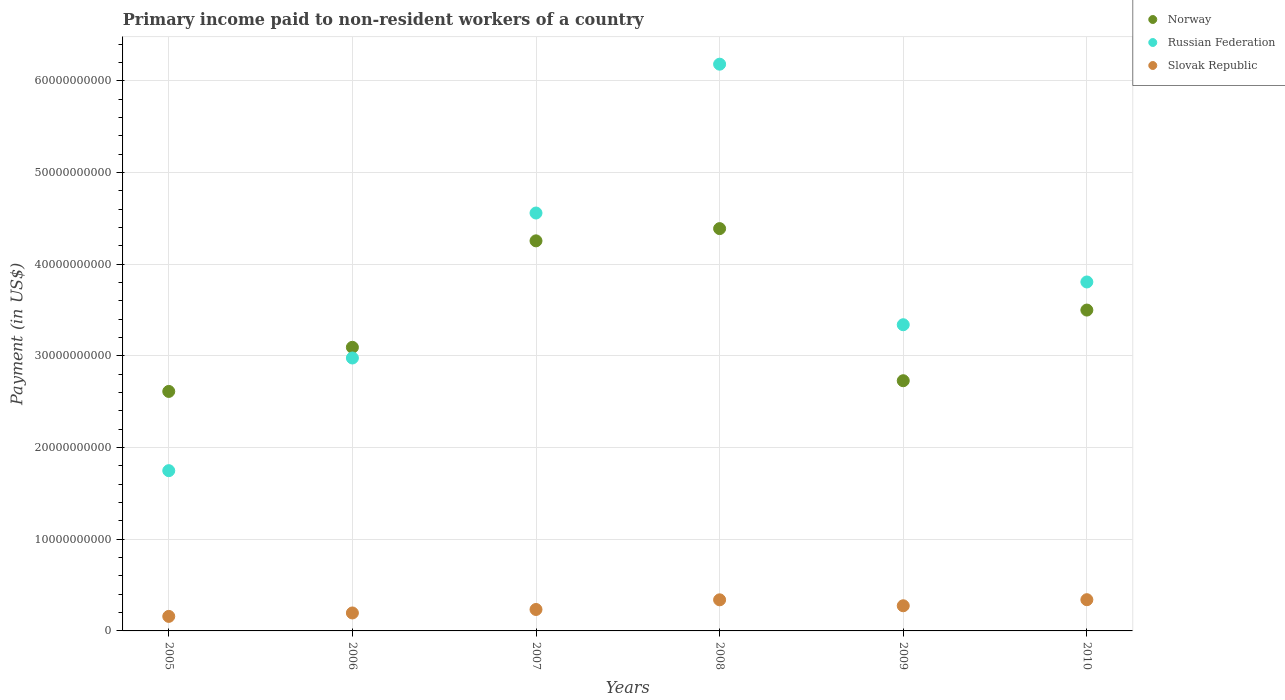How many different coloured dotlines are there?
Offer a terse response. 3. What is the amount paid to workers in Russian Federation in 2010?
Your response must be concise. 3.81e+1. Across all years, what is the maximum amount paid to workers in Slovak Republic?
Make the answer very short. 3.41e+09. Across all years, what is the minimum amount paid to workers in Russian Federation?
Keep it short and to the point. 1.75e+1. In which year was the amount paid to workers in Slovak Republic maximum?
Offer a very short reply. 2010. In which year was the amount paid to workers in Russian Federation minimum?
Keep it short and to the point. 2005. What is the total amount paid to workers in Norway in the graph?
Provide a succinct answer. 2.06e+11. What is the difference between the amount paid to workers in Slovak Republic in 2008 and that in 2009?
Offer a very short reply. 6.49e+08. What is the difference between the amount paid to workers in Norway in 2005 and the amount paid to workers in Slovak Republic in 2010?
Your response must be concise. 2.27e+1. What is the average amount paid to workers in Norway per year?
Make the answer very short. 3.43e+1. In the year 2005, what is the difference between the amount paid to workers in Slovak Republic and amount paid to workers in Norway?
Provide a short and direct response. -2.45e+1. In how many years, is the amount paid to workers in Russian Federation greater than 20000000000 US$?
Offer a terse response. 5. What is the ratio of the amount paid to workers in Slovak Republic in 2005 to that in 2008?
Keep it short and to the point. 0.47. Is the amount paid to workers in Norway in 2007 less than that in 2009?
Keep it short and to the point. No. What is the difference between the highest and the second highest amount paid to workers in Norway?
Your answer should be very brief. 1.33e+09. What is the difference between the highest and the lowest amount paid to workers in Slovak Republic?
Your response must be concise. 1.82e+09. Is the sum of the amount paid to workers in Norway in 2005 and 2009 greater than the maximum amount paid to workers in Russian Federation across all years?
Your response must be concise. No. Does the amount paid to workers in Norway monotonically increase over the years?
Ensure brevity in your answer.  No. Is the amount paid to workers in Russian Federation strictly greater than the amount paid to workers in Slovak Republic over the years?
Your answer should be very brief. Yes. Is the amount paid to workers in Russian Federation strictly less than the amount paid to workers in Norway over the years?
Give a very brief answer. No. How many dotlines are there?
Your response must be concise. 3. How many years are there in the graph?
Your answer should be compact. 6. What is the difference between two consecutive major ticks on the Y-axis?
Provide a succinct answer. 1.00e+1. Are the values on the major ticks of Y-axis written in scientific E-notation?
Make the answer very short. No. Does the graph contain any zero values?
Keep it short and to the point. No. Does the graph contain grids?
Your answer should be very brief. Yes. Where does the legend appear in the graph?
Your response must be concise. Top right. How many legend labels are there?
Keep it short and to the point. 3. How are the legend labels stacked?
Keep it short and to the point. Vertical. What is the title of the graph?
Your answer should be compact. Primary income paid to non-resident workers of a country. What is the label or title of the Y-axis?
Give a very brief answer. Payment (in US$). What is the Payment (in US$) in Norway in 2005?
Provide a succinct answer. 2.61e+1. What is the Payment (in US$) in Russian Federation in 2005?
Your answer should be very brief. 1.75e+1. What is the Payment (in US$) in Slovak Republic in 2005?
Ensure brevity in your answer.  1.58e+09. What is the Payment (in US$) of Norway in 2006?
Provide a short and direct response. 3.09e+1. What is the Payment (in US$) of Russian Federation in 2006?
Your response must be concise. 2.98e+1. What is the Payment (in US$) in Slovak Republic in 2006?
Your response must be concise. 1.96e+09. What is the Payment (in US$) in Norway in 2007?
Provide a short and direct response. 4.25e+1. What is the Payment (in US$) of Russian Federation in 2007?
Keep it short and to the point. 4.56e+1. What is the Payment (in US$) in Slovak Republic in 2007?
Your answer should be very brief. 2.34e+09. What is the Payment (in US$) of Norway in 2008?
Keep it short and to the point. 4.39e+1. What is the Payment (in US$) in Russian Federation in 2008?
Your answer should be very brief. 6.18e+1. What is the Payment (in US$) in Slovak Republic in 2008?
Give a very brief answer. 3.39e+09. What is the Payment (in US$) in Norway in 2009?
Keep it short and to the point. 2.73e+1. What is the Payment (in US$) in Russian Federation in 2009?
Provide a short and direct response. 3.34e+1. What is the Payment (in US$) in Slovak Republic in 2009?
Your answer should be compact. 2.74e+09. What is the Payment (in US$) in Norway in 2010?
Provide a short and direct response. 3.50e+1. What is the Payment (in US$) of Russian Federation in 2010?
Make the answer very short. 3.81e+1. What is the Payment (in US$) in Slovak Republic in 2010?
Provide a succinct answer. 3.41e+09. Across all years, what is the maximum Payment (in US$) of Norway?
Provide a short and direct response. 4.39e+1. Across all years, what is the maximum Payment (in US$) of Russian Federation?
Provide a succinct answer. 6.18e+1. Across all years, what is the maximum Payment (in US$) of Slovak Republic?
Your answer should be very brief. 3.41e+09. Across all years, what is the minimum Payment (in US$) of Norway?
Your response must be concise. 2.61e+1. Across all years, what is the minimum Payment (in US$) of Russian Federation?
Provide a succinct answer. 1.75e+1. Across all years, what is the minimum Payment (in US$) in Slovak Republic?
Your response must be concise. 1.58e+09. What is the total Payment (in US$) in Norway in the graph?
Offer a very short reply. 2.06e+11. What is the total Payment (in US$) of Russian Federation in the graph?
Your answer should be very brief. 2.26e+11. What is the total Payment (in US$) of Slovak Republic in the graph?
Make the answer very short. 1.54e+1. What is the difference between the Payment (in US$) in Norway in 2005 and that in 2006?
Ensure brevity in your answer.  -4.81e+09. What is the difference between the Payment (in US$) of Russian Federation in 2005 and that in 2006?
Ensure brevity in your answer.  -1.23e+1. What is the difference between the Payment (in US$) in Slovak Republic in 2005 and that in 2006?
Provide a short and direct response. -3.74e+08. What is the difference between the Payment (in US$) in Norway in 2005 and that in 2007?
Provide a succinct answer. -1.64e+1. What is the difference between the Payment (in US$) in Russian Federation in 2005 and that in 2007?
Give a very brief answer. -2.81e+1. What is the difference between the Payment (in US$) of Slovak Republic in 2005 and that in 2007?
Offer a very short reply. -7.55e+08. What is the difference between the Payment (in US$) in Norway in 2005 and that in 2008?
Provide a short and direct response. -1.78e+1. What is the difference between the Payment (in US$) in Russian Federation in 2005 and that in 2008?
Your response must be concise. -4.43e+1. What is the difference between the Payment (in US$) in Slovak Republic in 2005 and that in 2008?
Provide a short and direct response. -1.81e+09. What is the difference between the Payment (in US$) in Norway in 2005 and that in 2009?
Make the answer very short. -1.17e+09. What is the difference between the Payment (in US$) in Russian Federation in 2005 and that in 2009?
Your answer should be very brief. -1.59e+1. What is the difference between the Payment (in US$) in Slovak Republic in 2005 and that in 2009?
Your answer should be very brief. -1.16e+09. What is the difference between the Payment (in US$) of Norway in 2005 and that in 2010?
Give a very brief answer. -8.88e+09. What is the difference between the Payment (in US$) in Russian Federation in 2005 and that in 2010?
Your answer should be compact. -2.06e+1. What is the difference between the Payment (in US$) in Slovak Republic in 2005 and that in 2010?
Make the answer very short. -1.82e+09. What is the difference between the Payment (in US$) of Norway in 2006 and that in 2007?
Provide a short and direct response. -1.16e+1. What is the difference between the Payment (in US$) in Russian Federation in 2006 and that in 2007?
Make the answer very short. -1.58e+1. What is the difference between the Payment (in US$) in Slovak Republic in 2006 and that in 2007?
Your answer should be compact. -3.81e+08. What is the difference between the Payment (in US$) in Norway in 2006 and that in 2008?
Give a very brief answer. -1.29e+1. What is the difference between the Payment (in US$) in Russian Federation in 2006 and that in 2008?
Your answer should be very brief. -3.20e+1. What is the difference between the Payment (in US$) of Slovak Republic in 2006 and that in 2008?
Provide a succinct answer. -1.43e+09. What is the difference between the Payment (in US$) of Norway in 2006 and that in 2009?
Give a very brief answer. 3.64e+09. What is the difference between the Payment (in US$) of Russian Federation in 2006 and that in 2009?
Provide a succinct answer. -3.63e+09. What is the difference between the Payment (in US$) in Slovak Republic in 2006 and that in 2009?
Offer a very short reply. -7.85e+08. What is the difference between the Payment (in US$) of Norway in 2006 and that in 2010?
Keep it short and to the point. -4.06e+09. What is the difference between the Payment (in US$) in Russian Federation in 2006 and that in 2010?
Keep it short and to the point. -8.29e+09. What is the difference between the Payment (in US$) of Slovak Republic in 2006 and that in 2010?
Offer a terse response. -1.45e+09. What is the difference between the Payment (in US$) in Norway in 2007 and that in 2008?
Your answer should be very brief. -1.33e+09. What is the difference between the Payment (in US$) of Russian Federation in 2007 and that in 2008?
Provide a short and direct response. -1.62e+1. What is the difference between the Payment (in US$) in Slovak Republic in 2007 and that in 2008?
Your answer should be compact. -1.05e+09. What is the difference between the Payment (in US$) in Norway in 2007 and that in 2009?
Offer a very short reply. 1.53e+1. What is the difference between the Payment (in US$) of Russian Federation in 2007 and that in 2009?
Offer a very short reply. 1.22e+1. What is the difference between the Payment (in US$) of Slovak Republic in 2007 and that in 2009?
Ensure brevity in your answer.  -4.04e+08. What is the difference between the Payment (in US$) of Norway in 2007 and that in 2010?
Your answer should be compact. 7.55e+09. What is the difference between the Payment (in US$) of Russian Federation in 2007 and that in 2010?
Offer a very short reply. 7.52e+09. What is the difference between the Payment (in US$) of Slovak Republic in 2007 and that in 2010?
Provide a succinct answer. -1.07e+09. What is the difference between the Payment (in US$) in Norway in 2008 and that in 2009?
Offer a terse response. 1.66e+1. What is the difference between the Payment (in US$) in Russian Federation in 2008 and that in 2009?
Provide a succinct answer. 2.84e+1. What is the difference between the Payment (in US$) of Slovak Republic in 2008 and that in 2009?
Your response must be concise. 6.49e+08. What is the difference between the Payment (in US$) in Norway in 2008 and that in 2010?
Give a very brief answer. 8.88e+09. What is the difference between the Payment (in US$) of Russian Federation in 2008 and that in 2010?
Your answer should be compact. 2.38e+1. What is the difference between the Payment (in US$) in Slovak Republic in 2008 and that in 2010?
Your response must be concise. -1.33e+07. What is the difference between the Payment (in US$) of Norway in 2009 and that in 2010?
Ensure brevity in your answer.  -7.71e+09. What is the difference between the Payment (in US$) of Russian Federation in 2009 and that in 2010?
Offer a terse response. -4.66e+09. What is the difference between the Payment (in US$) in Slovak Republic in 2009 and that in 2010?
Offer a terse response. -6.62e+08. What is the difference between the Payment (in US$) of Norway in 2005 and the Payment (in US$) of Russian Federation in 2006?
Offer a very short reply. -3.65e+09. What is the difference between the Payment (in US$) of Norway in 2005 and the Payment (in US$) of Slovak Republic in 2006?
Provide a succinct answer. 2.42e+1. What is the difference between the Payment (in US$) in Russian Federation in 2005 and the Payment (in US$) in Slovak Republic in 2006?
Your answer should be compact. 1.55e+1. What is the difference between the Payment (in US$) of Norway in 2005 and the Payment (in US$) of Russian Federation in 2007?
Give a very brief answer. -1.95e+1. What is the difference between the Payment (in US$) of Norway in 2005 and the Payment (in US$) of Slovak Republic in 2007?
Make the answer very short. 2.38e+1. What is the difference between the Payment (in US$) of Russian Federation in 2005 and the Payment (in US$) of Slovak Republic in 2007?
Offer a terse response. 1.51e+1. What is the difference between the Payment (in US$) of Norway in 2005 and the Payment (in US$) of Russian Federation in 2008?
Provide a succinct answer. -3.57e+1. What is the difference between the Payment (in US$) of Norway in 2005 and the Payment (in US$) of Slovak Republic in 2008?
Provide a succinct answer. 2.27e+1. What is the difference between the Payment (in US$) of Russian Federation in 2005 and the Payment (in US$) of Slovak Republic in 2008?
Offer a very short reply. 1.41e+1. What is the difference between the Payment (in US$) of Norway in 2005 and the Payment (in US$) of Russian Federation in 2009?
Ensure brevity in your answer.  -7.28e+09. What is the difference between the Payment (in US$) of Norway in 2005 and the Payment (in US$) of Slovak Republic in 2009?
Give a very brief answer. 2.34e+1. What is the difference between the Payment (in US$) in Russian Federation in 2005 and the Payment (in US$) in Slovak Republic in 2009?
Make the answer very short. 1.47e+1. What is the difference between the Payment (in US$) of Norway in 2005 and the Payment (in US$) of Russian Federation in 2010?
Make the answer very short. -1.19e+1. What is the difference between the Payment (in US$) of Norway in 2005 and the Payment (in US$) of Slovak Republic in 2010?
Offer a very short reply. 2.27e+1. What is the difference between the Payment (in US$) in Russian Federation in 2005 and the Payment (in US$) in Slovak Republic in 2010?
Give a very brief answer. 1.41e+1. What is the difference between the Payment (in US$) in Norway in 2006 and the Payment (in US$) in Russian Federation in 2007?
Offer a very short reply. -1.46e+1. What is the difference between the Payment (in US$) in Norway in 2006 and the Payment (in US$) in Slovak Republic in 2007?
Your answer should be compact. 2.86e+1. What is the difference between the Payment (in US$) of Russian Federation in 2006 and the Payment (in US$) of Slovak Republic in 2007?
Your response must be concise. 2.74e+1. What is the difference between the Payment (in US$) of Norway in 2006 and the Payment (in US$) of Russian Federation in 2008?
Provide a short and direct response. -3.09e+1. What is the difference between the Payment (in US$) of Norway in 2006 and the Payment (in US$) of Slovak Republic in 2008?
Keep it short and to the point. 2.75e+1. What is the difference between the Payment (in US$) in Russian Federation in 2006 and the Payment (in US$) in Slovak Republic in 2008?
Your answer should be very brief. 2.64e+1. What is the difference between the Payment (in US$) of Norway in 2006 and the Payment (in US$) of Russian Federation in 2009?
Provide a short and direct response. -2.46e+09. What is the difference between the Payment (in US$) in Norway in 2006 and the Payment (in US$) in Slovak Republic in 2009?
Keep it short and to the point. 2.82e+1. What is the difference between the Payment (in US$) of Russian Federation in 2006 and the Payment (in US$) of Slovak Republic in 2009?
Give a very brief answer. 2.70e+1. What is the difference between the Payment (in US$) of Norway in 2006 and the Payment (in US$) of Russian Federation in 2010?
Offer a terse response. -7.13e+09. What is the difference between the Payment (in US$) of Norway in 2006 and the Payment (in US$) of Slovak Republic in 2010?
Your response must be concise. 2.75e+1. What is the difference between the Payment (in US$) of Russian Federation in 2006 and the Payment (in US$) of Slovak Republic in 2010?
Offer a very short reply. 2.64e+1. What is the difference between the Payment (in US$) in Norway in 2007 and the Payment (in US$) in Russian Federation in 2008?
Give a very brief answer. -1.93e+1. What is the difference between the Payment (in US$) in Norway in 2007 and the Payment (in US$) in Slovak Republic in 2008?
Your answer should be very brief. 3.92e+1. What is the difference between the Payment (in US$) in Russian Federation in 2007 and the Payment (in US$) in Slovak Republic in 2008?
Your answer should be compact. 4.22e+1. What is the difference between the Payment (in US$) in Norway in 2007 and the Payment (in US$) in Russian Federation in 2009?
Offer a terse response. 9.15e+09. What is the difference between the Payment (in US$) in Norway in 2007 and the Payment (in US$) in Slovak Republic in 2009?
Give a very brief answer. 3.98e+1. What is the difference between the Payment (in US$) in Russian Federation in 2007 and the Payment (in US$) in Slovak Republic in 2009?
Provide a short and direct response. 4.28e+1. What is the difference between the Payment (in US$) in Norway in 2007 and the Payment (in US$) in Russian Federation in 2010?
Offer a terse response. 4.49e+09. What is the difference between the Payment (in US$) of Norway in 2007 and the Payment (in US$) of Slovak Republic in 2010?
Make the answer very short. 3.91e+1. What is the difference between the Payment (in US$) of Russian Federation in 2007 and the Payment (in US$) of Slovak Republic in 2010?
Provide a succinct answer. 4.22e+1. What is the difference between the Payment (in US$) of Norway in 2008 and the Payment (in US$) of Russian Federation in 2009?
Your answer should be compact. 1.05e+1. What is the difference between the Payment (in US$) in Norway in 2008 and the Payment (in US$) in Slovak Republic in 2009?
Offer a very short reply. 4.11e+1. What is the difference between the Payment (in US$) of Russian Federation in 2008 and the Payment (in US$) of Slovak Republic in 2009?
Provide a succinct answer. 5.91e+1. What is the difference between the Payment (in US$) in Norway in 2008 and the Payment (in US$) in Russian Federation in 2010?
Make the answer very short. 5.82e+09. What is the difference between the Payment (in US$) in Norway in 2008 and the Payment (in US$) in Slovak Republic in 2010?
Offer a very short reply. 4.05e+1. What is the difference between the Payment (in US$) in Russian Federation in 2008 and the Payment (in US$) in Slovak Republic in 2010?
Keep it short and to the point. 5.84e+1. What is the difference between the Payment (in US$) of Norway in 2009 and the Payment (in US$) of Russian Federation in 2010?
Make the answer very short. -1.08e+1. What is the difference between the Payment (in US$) of Norway in 2009 and the Payment (in US$) of Slovak Republic in 2010?
Your answer should be compact. 2.39e+1. What is the difference between the Payment (in US$) of Russian Federation in 2009 and the Payment (in US$) of Slovak Republic in 2010?
Ensure brevity in your answer.  3.00e+1. What is the average Payment (in US$) in Norway per year?
Give a very brief answer. 3.43e+1. What is the average Payment (in US$) of Russian Federation per year?
Provide a short and direct response. 3.77e+1. What is the average Payment (in US$) of Slovak Republic per year?
Make the answer very short. 2.57e+09. In the year 2005, what is the difference between the Payment (in US$) in Norway and Payment (in US$) in Russian Federation?
Your answer should be very brief. 8.64e+09. In the year 2005, what is the difference between the Payment (in US$) of Norway and Payment (in US$) of Slovak Republic?
Keep it short and to the point. 2.45e+1. In the year 2005, what is the difference between the Payment (in US$) of Russian Federation and Payment (in US$) of Slovak Republic?
Make the answer very short. 1.59e+1. In the year 2006, what is the difference between the Payment (in US$) of Norway and Payment (in US$) of Russian Federation?
Your answer should be very brief. 1.17e+09. In the year 2006, what is the difference between the Payment (in US$) of Norway and Payment (in US$) of Slovak Republic?
Offer a terse response. 2.90e+1. In the year 2006, what is the difference between the Payment (in US$) in Russian Federation and Payment (in US$) in Slovak Republic?
Keep it short and to the point. 2.78e+1. In the year 2007, what is the difference between the Payment (in US$) of Norway and Payment (in US$) of Russian Federation?
Offer a very short reply. -3.03e+09. In the year 2007, what is the difference between the Payment (in US$) of Norway and Payment (in US$) of Slovak Republic?
Your response must be concise. 4.02e+1. In the year 2007, what is the difference between the Payment (in US$) in Russian Federation and Payment (in US$) in Slovak Republic?
Your answer should be very brief. 4.32e+1. In the year 2008, what is the difference between the Payment (in US$) of Norway and Payment (in US$) of Russian Federation?
Offer a very short reply. -1.79e+1. In the year 2008, what is the difference between the Payment (in US$) of Norway and Payment (in US$) of Slovak Republic?
Keep it short and to the point. 4.05e+1. In the year 2008, what is the difference between the Payment (in US$) in Russian Federation and Payment (in US$) in Slovak Republic?
Keep it short and to the point. 5.84e+1. In the year 2009, what is the difference between the Payment (in US$) in Norway and Payment (in US$) in Russian Federation?
Provide a short and direct response. -6.11e+09. In the year 2009, what is the difference between the Payment (in US$) of Norway and Payment (in US$) of Slovak Republic?
Your answer should be very brief. 2.45e+1. In the year 2009, what is the difference between the Payment (in US$) of Russian Federation and Payment (in US$) of Slovak Republic?
Ensure brevity in your answer.  3.07e+1. In the year 2010, what is the difference between the Payment (in US$) of Norway and Payment (in US$) of Russian Federation?
Your response must be concise. -3.06e+09. In the year 2010, what is the difference between the Payment (in US$) of Norway and Payment (in US$) of Slovak Republic?
Provide a short and direct response. 3.16e+1. In the year 2010, what is the difference between the Payment (in US$) in Russian Federation and Payment (in US$) in Slovak Republic?
Make the answer very short. 3.47e+1. What is the ratio of the Payment (in US$) of Norway in 2005 to that in 2006?
Offer a very short reply. 0.84. What is the ratio of the Payment (in US$) of Russian Federation in 2005 to that in 2006?
Provide a short and direct response. 0.59. What is the ratio of the Payment (in US$) of Slovak Republic in 2005 to that in 2006?
Your answer should be compact. 0.81. What is the ratio of the Payment (in US$) in Norway in 2005 to that in 2007?
Keep it short and to the point. 0.61. What is the ratio of the Payment (in US$) in Russian Federation in 2005 to that in 2007?
Keep it short and to the point. 0.38. What is the ratio of the Payment (in US$) of Slovak Republic in 2005 to that in 2007?
Keep it short and to the point. 0.68. What is the ratio of the Payment (in US$) of Norway in 2005 to that in 2008?
Offer a terse response. 0.6. What is the ratio of the Payment (in US$) in Russian Federation in 2005 to that in 2008?
Keep it short and to the point. 0.28. What is the ratio of the Payment (in US$) of Slovak Republic in 2005 to that in 2008?
Your answer should be compact. 0.47. What is the ratio of the Payment (in US$) of Norway in 2005 to that in 2009?
Your response must be concise. 0.96. What is the ratio of the Payment (in US$) in Russian Federation in 2005 to that in 2009?
Your response must be concise. 0.52. What is the ratio of the Payment (in US$) of Slovak Republic in 2005 to that in 2009?
Ensure brevity in your answer.  0.58. What is the ratio of the Payment (in US$) in Norway in 2005 to that in 2010?
Your answer should be very brief. 0.75. What is the ratio of the Payment (in US$) in Russian Federation in 2005 to that in 2010?
Ensure brevity in your answer.  0.46. What is the ratio of the Payment (in US$) of Slovak Republic in 2005 to that in 2010?
Offer a terse response. 0.47. What is the ratio of the Payment (in US$) in Norway in 2006 to that in 2007?
Offer a very short reply. 0.73. What is the ratio of the Payment (in US$) in Russian Federation in 2006 to that in 2007?
Your answer should be very brief. 0.65. What is the ratio of the Payment (in US$) of Slovak Republic in 2006 to that in 2007?
Ensure brevity in your answer.  0.84. What is the ratio of the Payment (in US$) of Norway in 2006 to that in 2008?
Your answer should be very brief. 0.7. What is the ratio of the Payment (in US$) of Russian Federation in 2006 to that in 2008?
Give a very brief answer. 0.48. What is the ratio of the Payment (in US$) in Slovak Republic in 2006 to that in 2008?
Offer a terse response. 0.58. What is the ratio of the Payment (in US$) of Norway in 2006 to that in 2009?
Provide a short and direct response. 1.13. What is the ratio of the Payment (in US$) of Russian Federation in 2006 to that in 2009?
Your answer should be very brief. 0.89. What is the ratio of the Payment (in US$) in Slovak Republic in 2006 to that in 2009?
Offer a very short reply. 0.71. What is the ratio of the Payment (in US$) in Norway in 2006 to that in 2010?
Keep it short and to the point. 0.88. What is the ratio of the Payment (in US$) of Russian Federation in 2006 to that in 2010?
Keep it short and to the point. 0.78. What is the ratio of the Payment (in US$) in Slovak Republic in 2006 to that in 2010?
Give a very brief answer. 0.58. What is the ratio of the Payment (in US$) in Norway in 2007 to that in 2008?
Ensure brevity in your answer.  0.97. What is the ratio of the Payment (in US$) of Russian Federation in 2007 to that in 2008?
Your response must be concise. 0.74. What is the ratio of the Payment (in US$) of Slovak Republic in 2007 to that in 2008?
Provide a short and direct response. 0.69. What is the ratio of the Payment (in US$) of Norway in 2007 to that in 2009?
Give a very brief answer. 1.56. What is the ratio of the Payment (in US$) of Russian Federation in 2007 to that in 2009?
Offer a terse response. 1.36. What is the ratio of the Payment (in US$) in Slovak Republic in 2007 to that in 2009?
Make the answer very short. 0.85. What is the ratio of the Payment (in US$) in Norway in 2007 to that in 2010?
Provide a short and direct response. 1.22. What is the ratio of the Payment (in US$) of Russian Federation in 2007 to that in 2010?
Give a very brief answer. 1.2. What is the ratio of the Payment (in US$) of Slovak Republic in 2007 to that in 2010?
Give a very brief answer. 0.69. What is the ratio of the Payment (in US$) of Norway in 2008 to that in 2009?
Provide a succinct answer. 1.61. What is the ratio of the Payment (in US$) of Russian Federation in 2008 to that in 2009?
Ensure brevity in your answer.  1.85. What is the ratio of the Payment (in US$) in Slovak Republic in 2008 to that in 2009?
Give a very brief answer. 1.24. What is the ratio of the Payment (in US$) in Norway in 2008 to that in 2010?
Provide a succinct answer. 1.25. What is the ratio of the Payment (in US$) in Russian Federation in 2008 to that in 2010?
Your response must be concise. 1.62. What is the ratio of the Payment (in US$) of Slovak Republic in 2008 to that in 2010?
Offer a very short reply. 1. What is the ratio of the Payment (in US$) in Norway in 2009 to that in 2010?
Provide a short and direct response. 0.78. What is the ratio of the Payment (in US$) of Russian Federation in 2009 to that in 2010?
Give a very brief answer. 0.88. What is the ratio of the Payment (in US$) in Slovak Republic in 2009 to that in 2010?
Provide a succinct answer. 0.81. What is the difference between the highest and the second highest Payment (in US$) in Norway?
Offer a terse response. 1.33e+09. What is the difference between the highest and the second highest Payment (in US$) of Russian Federation?
Your response must be concise. 1.62e+1. What is the difference between the highest and the second highest Payment (in US$) of Slovak Republic?
Your response must be concise. 1.33e+07. What is the difference between the highest and the lowest Payment (in US$) of Norway?
Your answer should be compact. 1.78e+1. What is the difference between the highest and the lowest Payment (in US$) in Russian Federation?
Make the answer very short. 4.43e+1. What is the difference between the highest and the lowest Payment (in US$) of Slovak Republic?
Your answer should be very brief. 1.82e+09. 